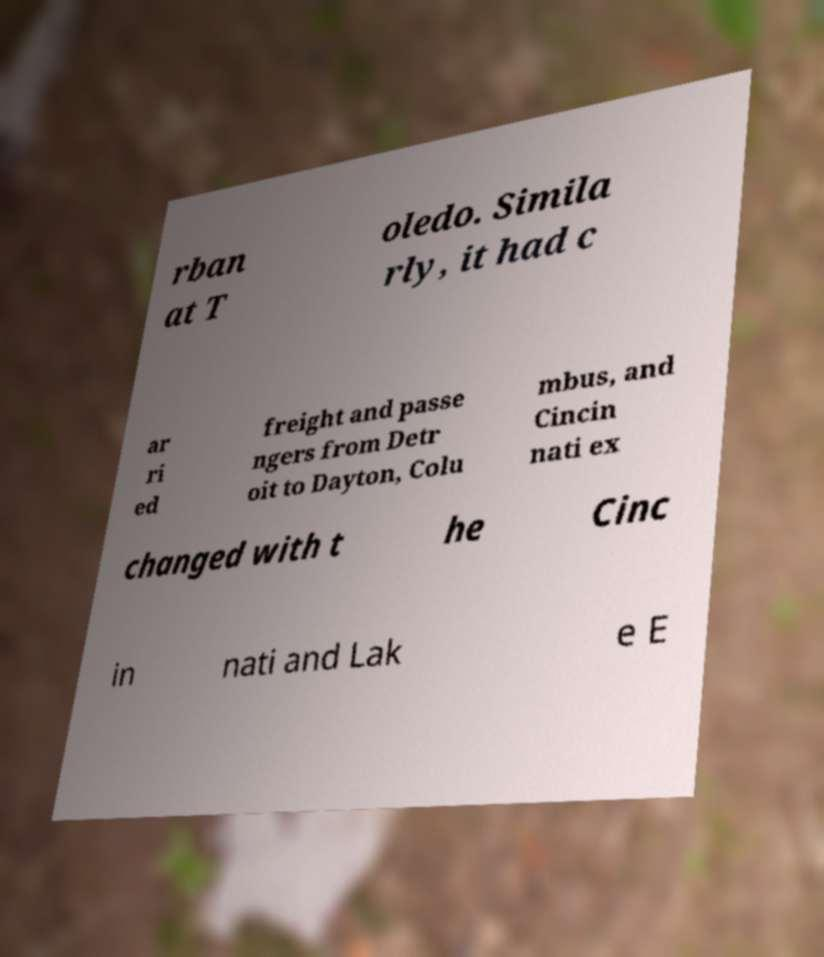Can you read and provide the text displayed in the image?This photo seems to have some interesting text. Can you extract and type it out for me? rban at T oledo. Simila rly, it had c ar ri ed freight and passe ngers from Detr oit to Dayton, Colu mbus, and Cincin nati ex changed with t he Cinc in nati and Lak e E 